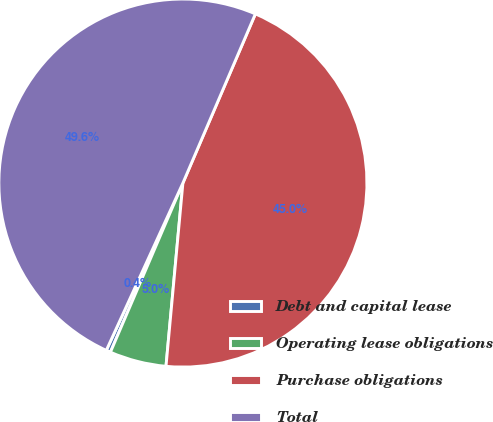Convert chart to OTSL. <chart><loc_0><loc_0><loc_500><loc_500><pie_chart><fcel>Debt and capital lease<fcel>Operating lease obligations<fcel>Purchase obligations<fcel>Total<nl><fcel>0.39%<fcel>4.98%<fcel>45.02%<fcel>49.61%<nl></chart> 